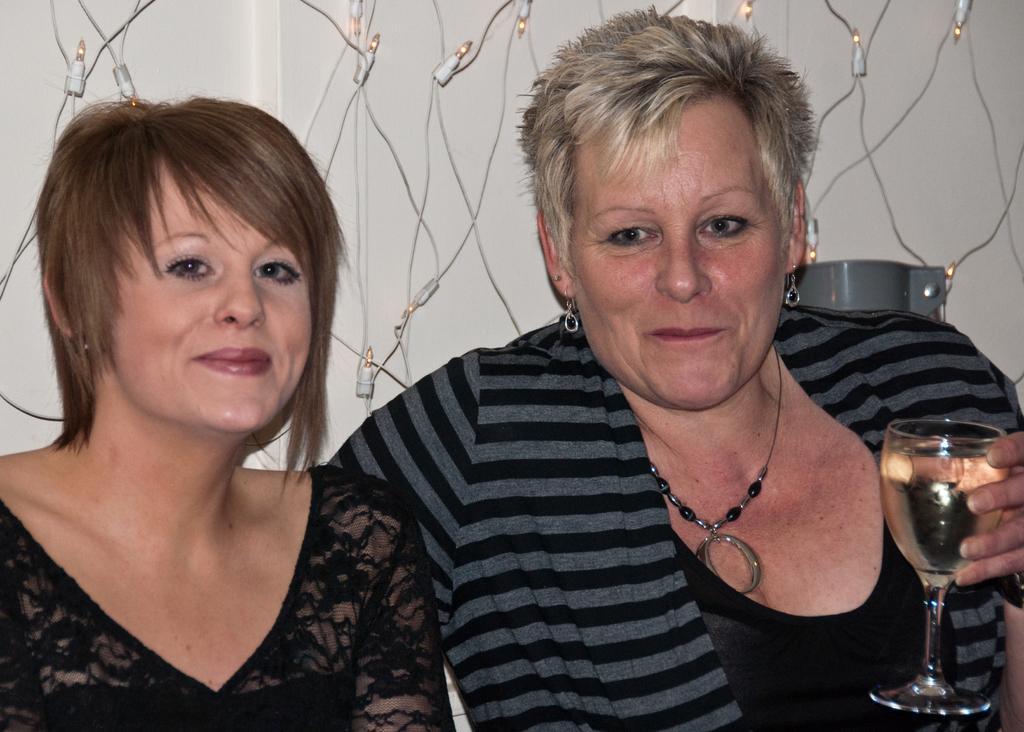Describe this image in one or two sentences. In this image two women are there. Right side woman is holding a glass which has a drink in it. Background there is a wall hanged with small lights and wires. 